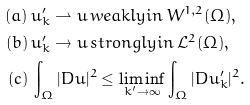<formula> <loc_0><loc_0><loc_500><loc_500>( a ) & \, u _ { k } ^ { \prime } \rightharpoonup u \, w e a k l y i n \, W ^ { 1 , 2 } ( \Omega ) , \\ ( b ) & \, u _ { k } ^ { \prime } \rightarrow u \, s t r o n g l y i n \, \mathcal { L } ^ { 2 } ( \Omega ) , \\ ( c ) & \, \int _ { \Omega } | D u | ^ { 2 } \leq \liminf _ { k ^ { \prime } \to \infty } \int _ { \Omega } | D u _ { k } ^ { \prime } | ^ { 2 } .</formula> 